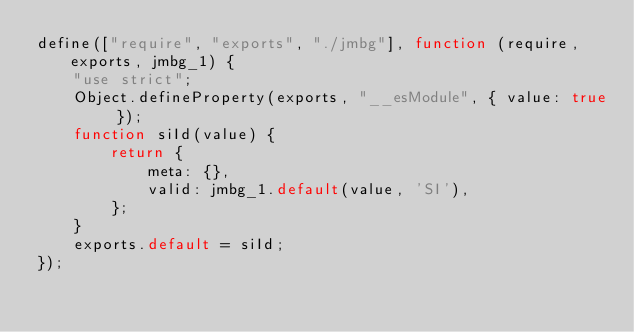Convert code to text. <code><loc_0><loc_0><loc_500><loc_500><_JavaScript_>define(["require", "exports", "./jmbg"], function (require, exports, jmbg_1) {
    "use strict";
    Object.defineProperty(exports, "__esModule", { value: true });
    function siId(value) {
        return {
            meta: {},
            valid: jmbg_1.default(value, 'SI'),
        };
    }
    exports.default = siId;
});
</code> 